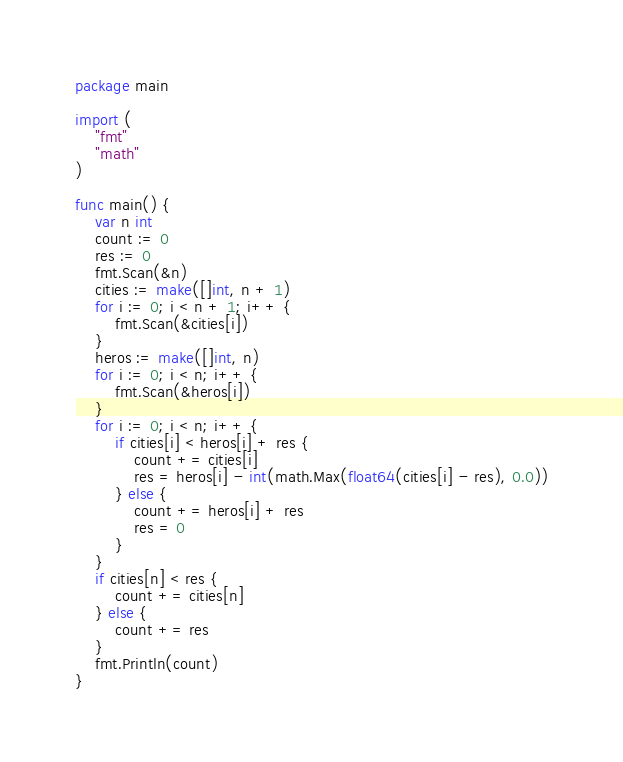<code> <loc_0><loc_0><loc_500><loc_500><_Go_>package main

import (
	"fmt"
	"math"
)

func main() {
	var n int
	count := 0
	res := 0
	fmt.Scan(&n)
	cities := make([]int, n + 1)
	for i := 0; i < n + 1; i++ {
		fmt.Scan(&cities[i])
	}
	heros := make([]int, n)
	for i := 0; i < n; i++ {
		fmt.Scan(&heros[i])
	}
	for i := 0; i < n; i++ {
		if cities[i] < heros[i] + res {
			count += cities[i]
			res = heros[i] - int(math.Max(float64(cities[i] - res), 0.0))
		} else {
			count += heros[i] + res
			res = 0
		}
	}
	if cities[n] < res {
		count += cities[n]
	} else {
		count += res
	}
	fmt.Println(count)
}
</code> 